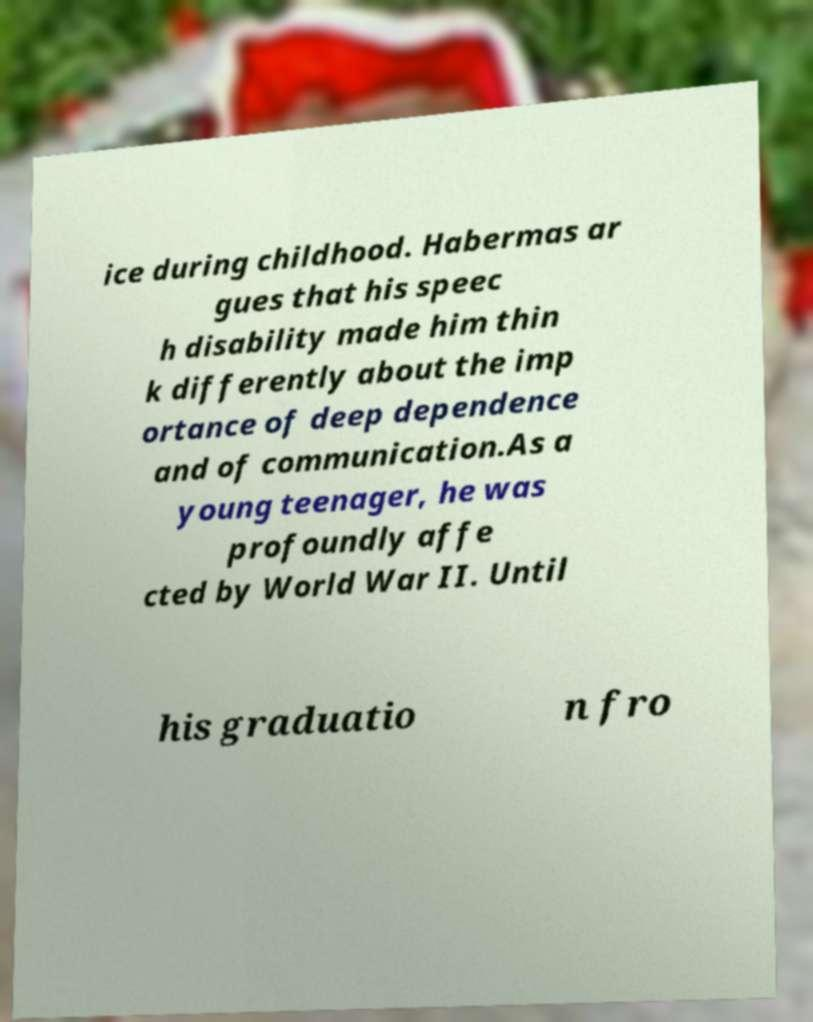Please identify and transcribe the text found in this image. ice during childhood. Habermas ar gues that his speec h disability made him thin k differently about the imp ortance of deep dependence and of communication.As a young teenager, he was profoundly affe cted by World War II. Until his graduatio n fro 